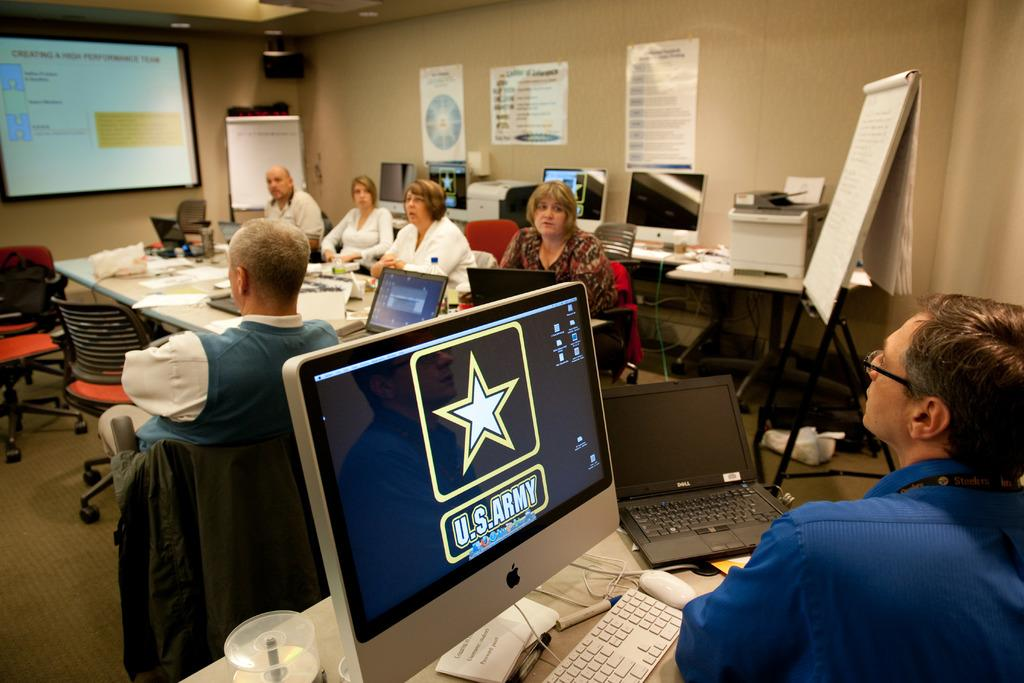<image>
Summarize the visual content of the image. A man sitting at a computer monitor that says U.S Army on it. 